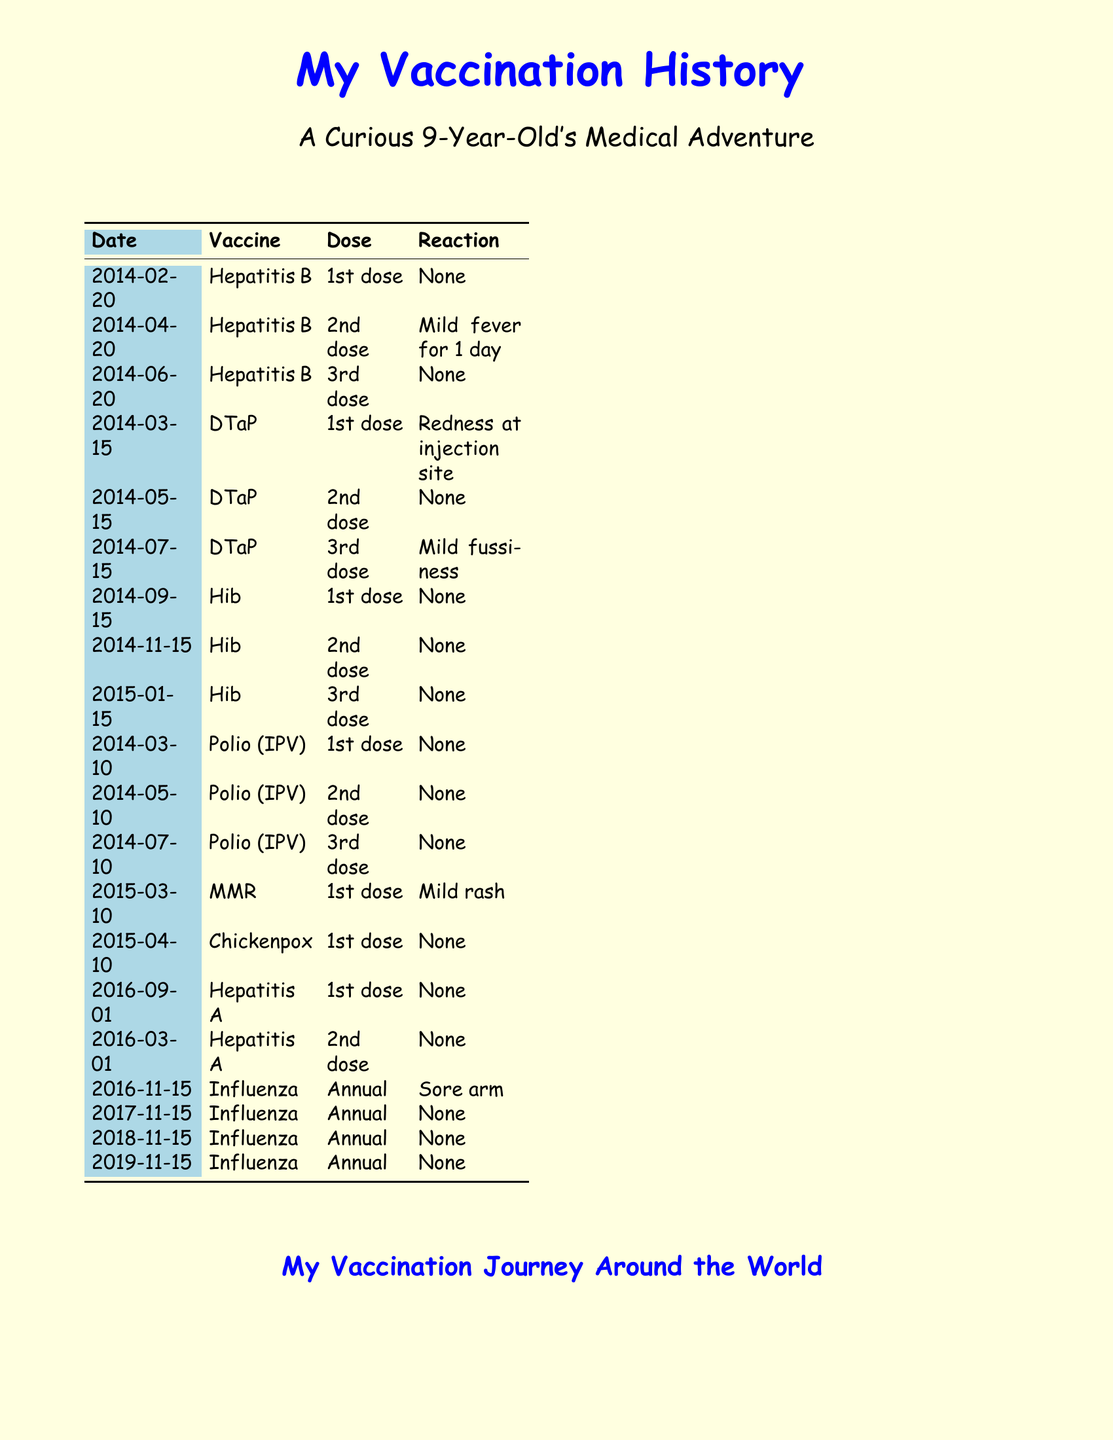What is the first vaccine received? The first vaccine received is listed with the date 2014-02-20 and is Hepatitis B.
Answer: Hepatitis B What date was the last flu vaccine administered? The last flu vaccination listed in the document is dated 2019-11-15.
Answer: 2019-11-15 How many doses of DTaP were given? The document shows three doses of DTaP were administered.
Answer: 3 What reaction was reported after the first MMR vaccine? The record indicates a mild rash as the reaction after the first MMR vaccine.
Answer: Mild rash Which vaccine had a reaction described as "redness at injection site"? The reaction described as "redness at injection site" is associated with the first dose of DTaP.
Answer: DTaP What type of document is this? This document is a detailed record of immunizations received since birth.
Answer: Medical record How many doses of Polio were administered? The record lists three doses of Polio (IPV) received.
Answer: 3 What was the reaction after the second Hepatitis A vaccine? The record indicates that there was no reaction after the second Hepatitis A vaccine.
Answer: None 